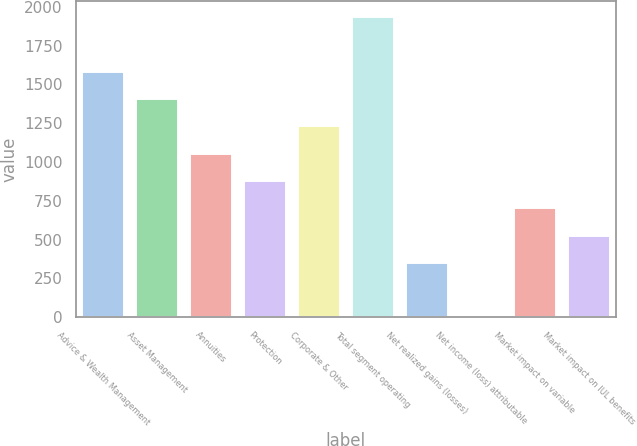Convert chart. <chart><loc_0><loc_0><loc_500><loc_500><bar_chart><fcel>Advice & Wealth Management<fcel>Asset Management<fcel>Annuities<fcel>Protection<fcel>Corporate & Other<fcel>Total segment operating<fcel>Net realized gains (losses)<fcel>Net income (loss) attributable<fcel>Market impact on variable<fcel>Market impact on IUL benefits<nl><fcel>1588.7<fcel>1412.4<fcel>1059.8<fcel>883.5<fcel>1236.1<fcel>1941.3<fcel>354.6<fcel>2<fcel>707.2<fcel>530.9<nl></chart> 